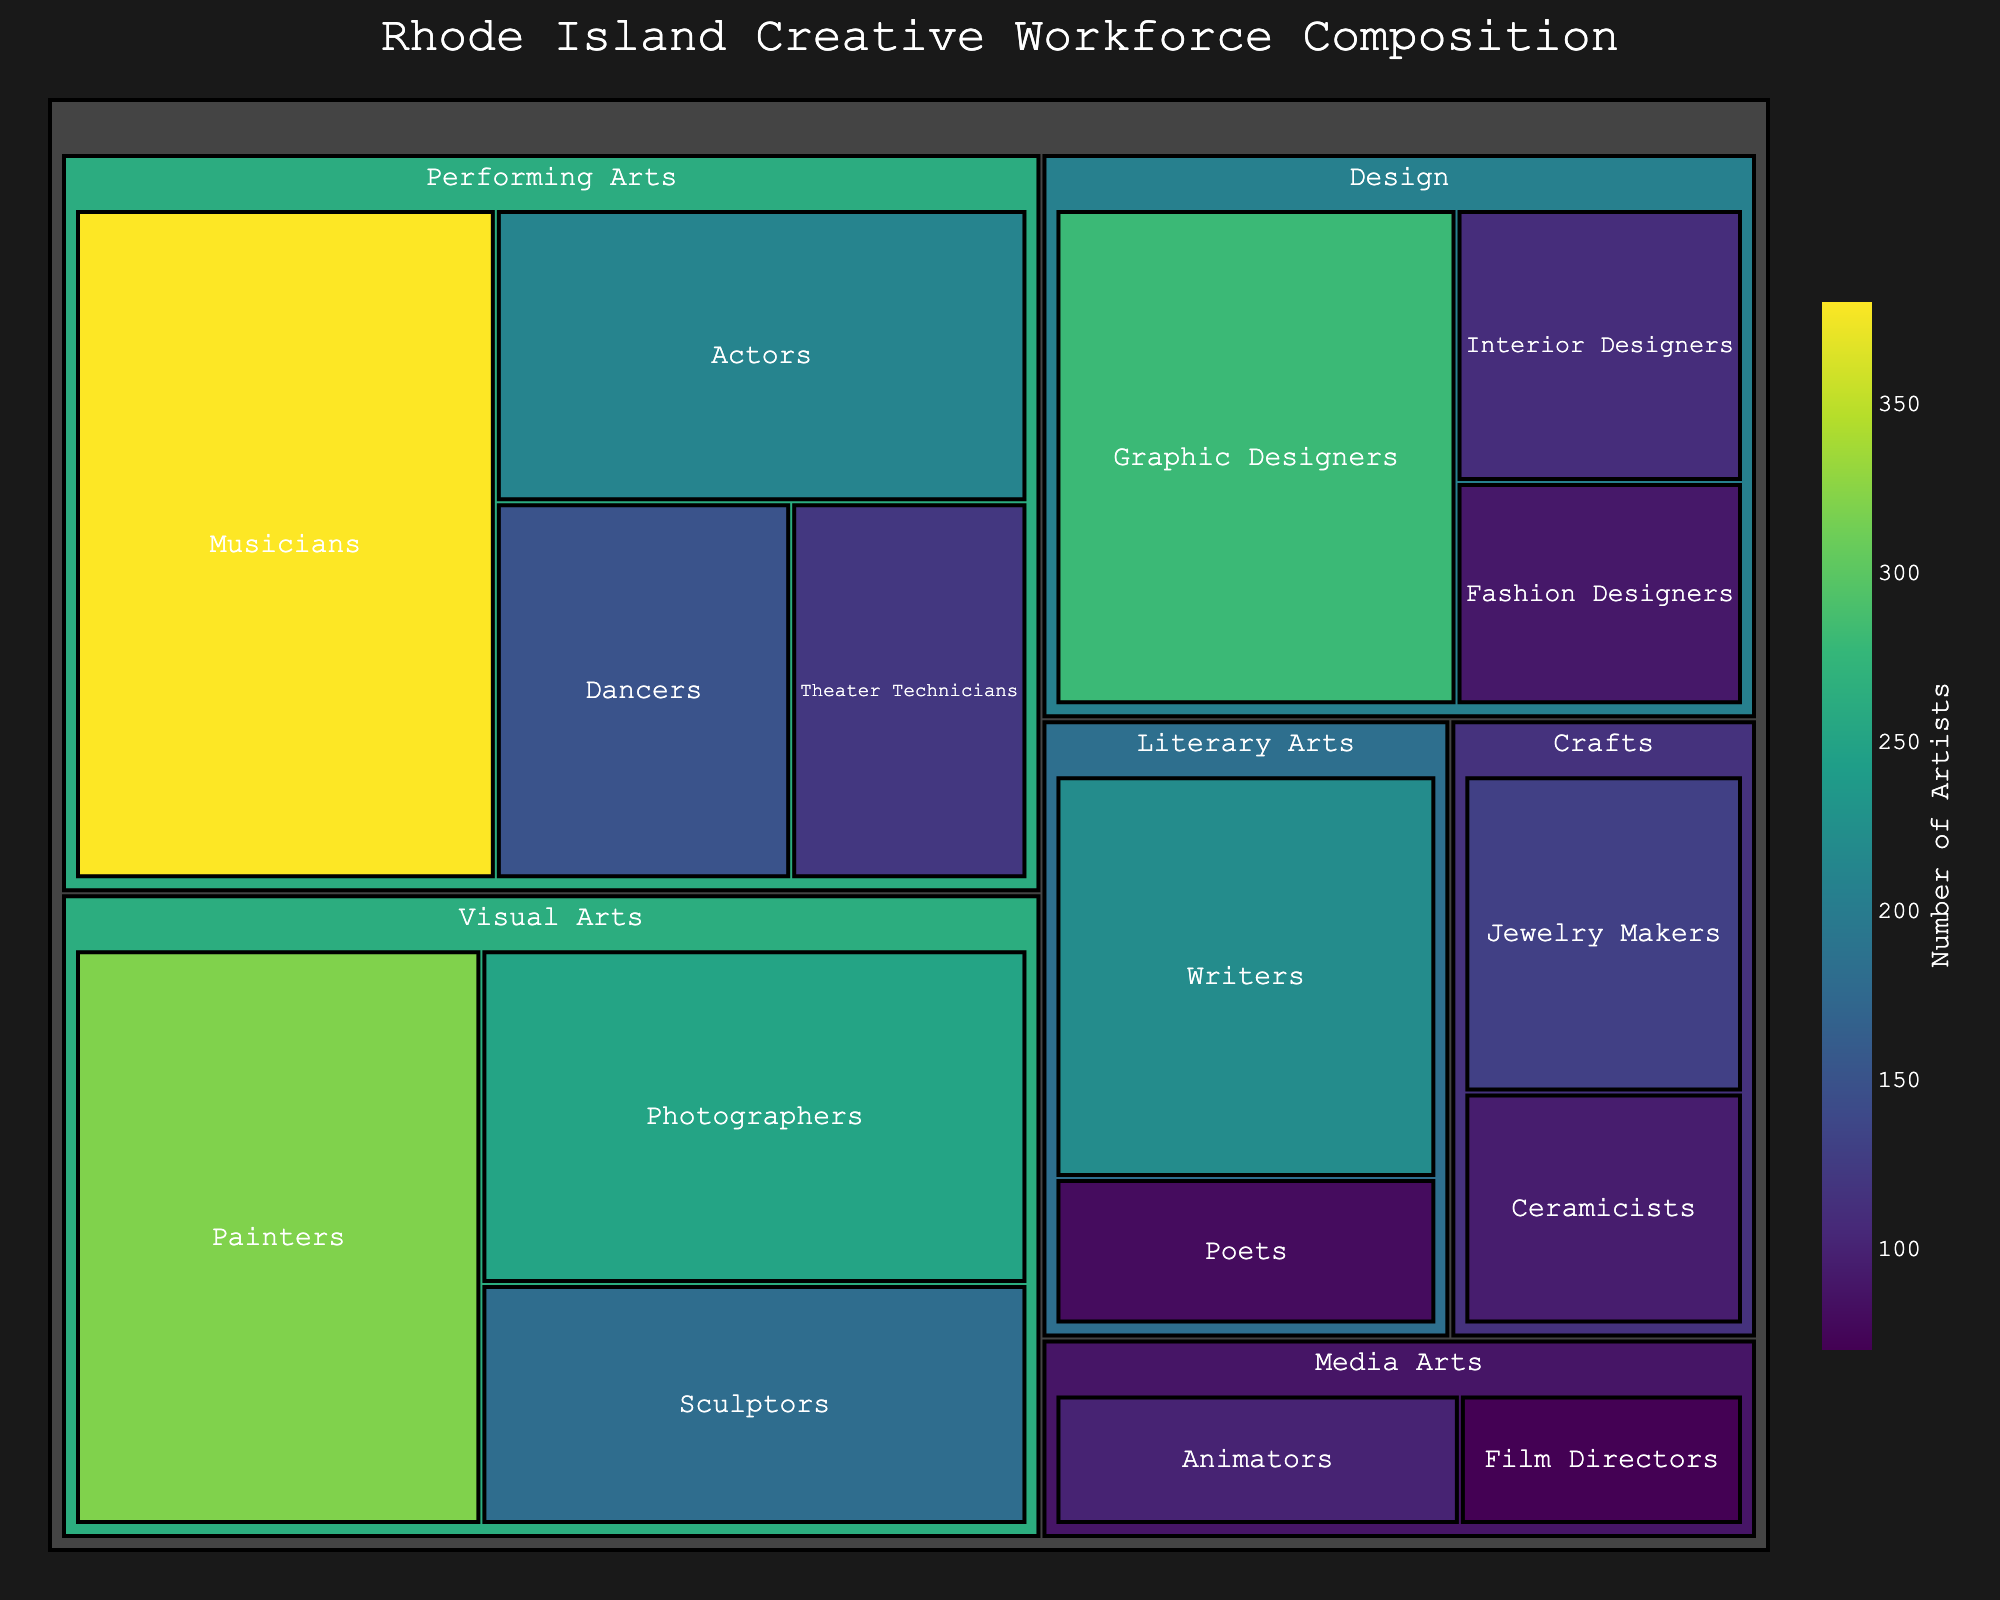What's the largest subcategory in the Visual Arts category? Look at the Visual Arts section of the treemap and find the subcategory with the highest number of artists. Painters have 320, Sculptors have 180, and Photographers have 250. The largest number is 320.
Answer: Painters Which has more artists, Musicians or Actors? Compare the values for Musicians and Actors in the Performing Arts section. Musicians have 380 artists, while Actors have 210. Therefore, Musicians have more artists.
Answer: Musicians What's the total number of artists in the Design category? Add the number of artists in each subcategory under Design: Graphic Designers (280), Fashion Designers (90), and Interior Designers (110). The total is 280 + 90 + 110 = 480.
Answer: 480 Which subcategory has the lowest representation in the entire treemap? Identify the subcategory with the smallest value across all categories. The values are 70 for Film Directors, 80 for Poets, and 90 for Fashion Designers. The lowest is 70.
Answer: Film Directors How many more Photographers are there than Jewelry Makers? Find the difference between the number of Photographers (250) and Jewelry Makers (130). The difference is 250 - 130 = 120.
Answer: 120 What is the combined number of artists in the Literary Arts category? Add the number of artists in the subcategories under Literary Arts: Writers (220) and Poets (80). The total is 220 + 80 = 300.
Answer: 300 What's the proportion of Musicians to the total number of artists in the Performing Arts category? First, calculate the total number of artists in Performing Arts by summing the subcategories: Actors (210), Musicians (380), Dancers (150), and Theater Technicians (120). The total is 210 + 380 + 150 + 120 = 860. Then, find the proportion of Musicians (380) to this total: 380 / 860 ≈ 0.442.
Answer: Approximately 44.2% Which is larger, the total number of artists in Crafts or Media Arts? Calculate the total number of artists in each category. For Crafts: Jewelry Makers (130) + Ceramicists (95) = 225. For Media Arts: Film Directors (70) + Animators (100) = 170. Crafts has the larger total.
Answer: Crafts How many artists are there in Visual Arts and Design combined? Sum the total number of artists in Visual Arts and Design categories. Visual Arts: Painters (320) + Sculptors (180) + Photographers (250) = 750. Design: 480. Combined total = 750 + 480 = 1230.
Answer: 1230 What category has the highest total number of artists? Sum the values within each category. Compare the totals: Visual Arts (750), Performing Arts (860), Design (480), Literary Arts (300), Media Arts (170), and Crafts (225). Performing Arts has the highest total with 860.
Answer: Performing Arts 